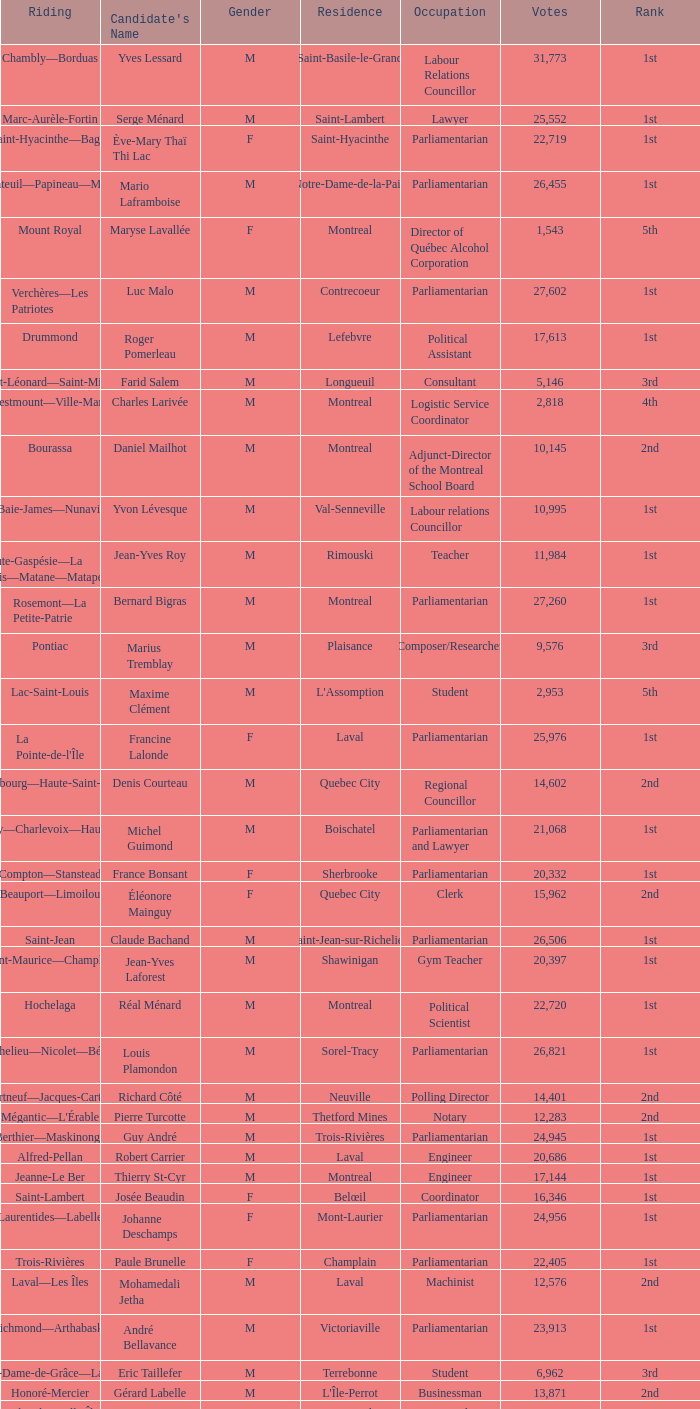What is the highest number of votes for the French Professor? 11625.0. 